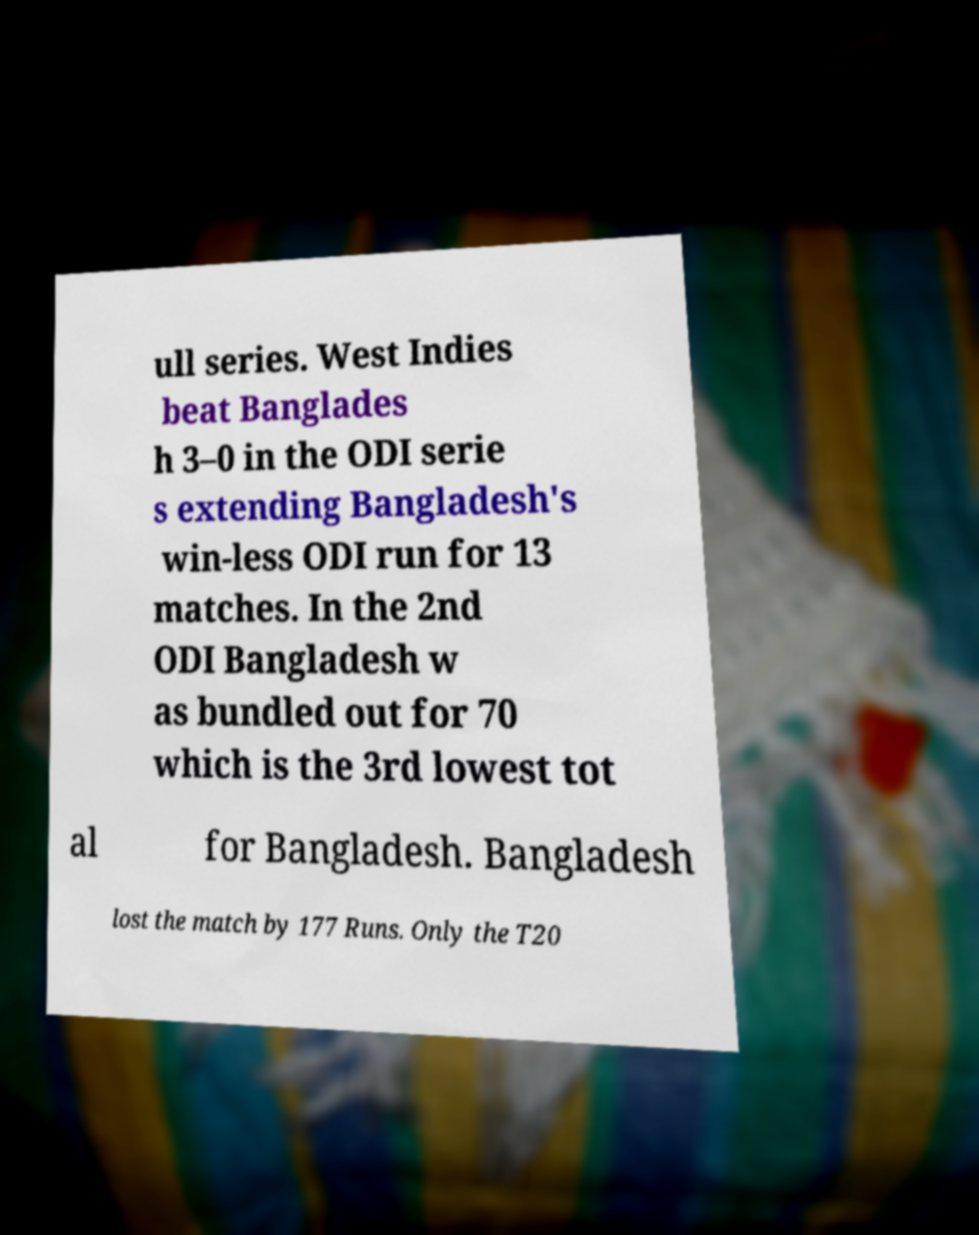Could you extract and type out the text from this image? ull series. West Indies beat Banglades h 3–0 in the ODI serie s extending Bangladesh's win-less ODI run for 13 matches. In the 2nd ODI Bangladesh w as bundled out for 70 which is the 3rd lowest tot al for Bangladesh. Bangladesh lost the match by 177 Runs. Only the T20 